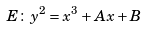<formula> <loc_0><loc_0><loc_500><loc_500>E \colon y ^ { 2 } = x ^ { 3 } + A x + B</formula> 